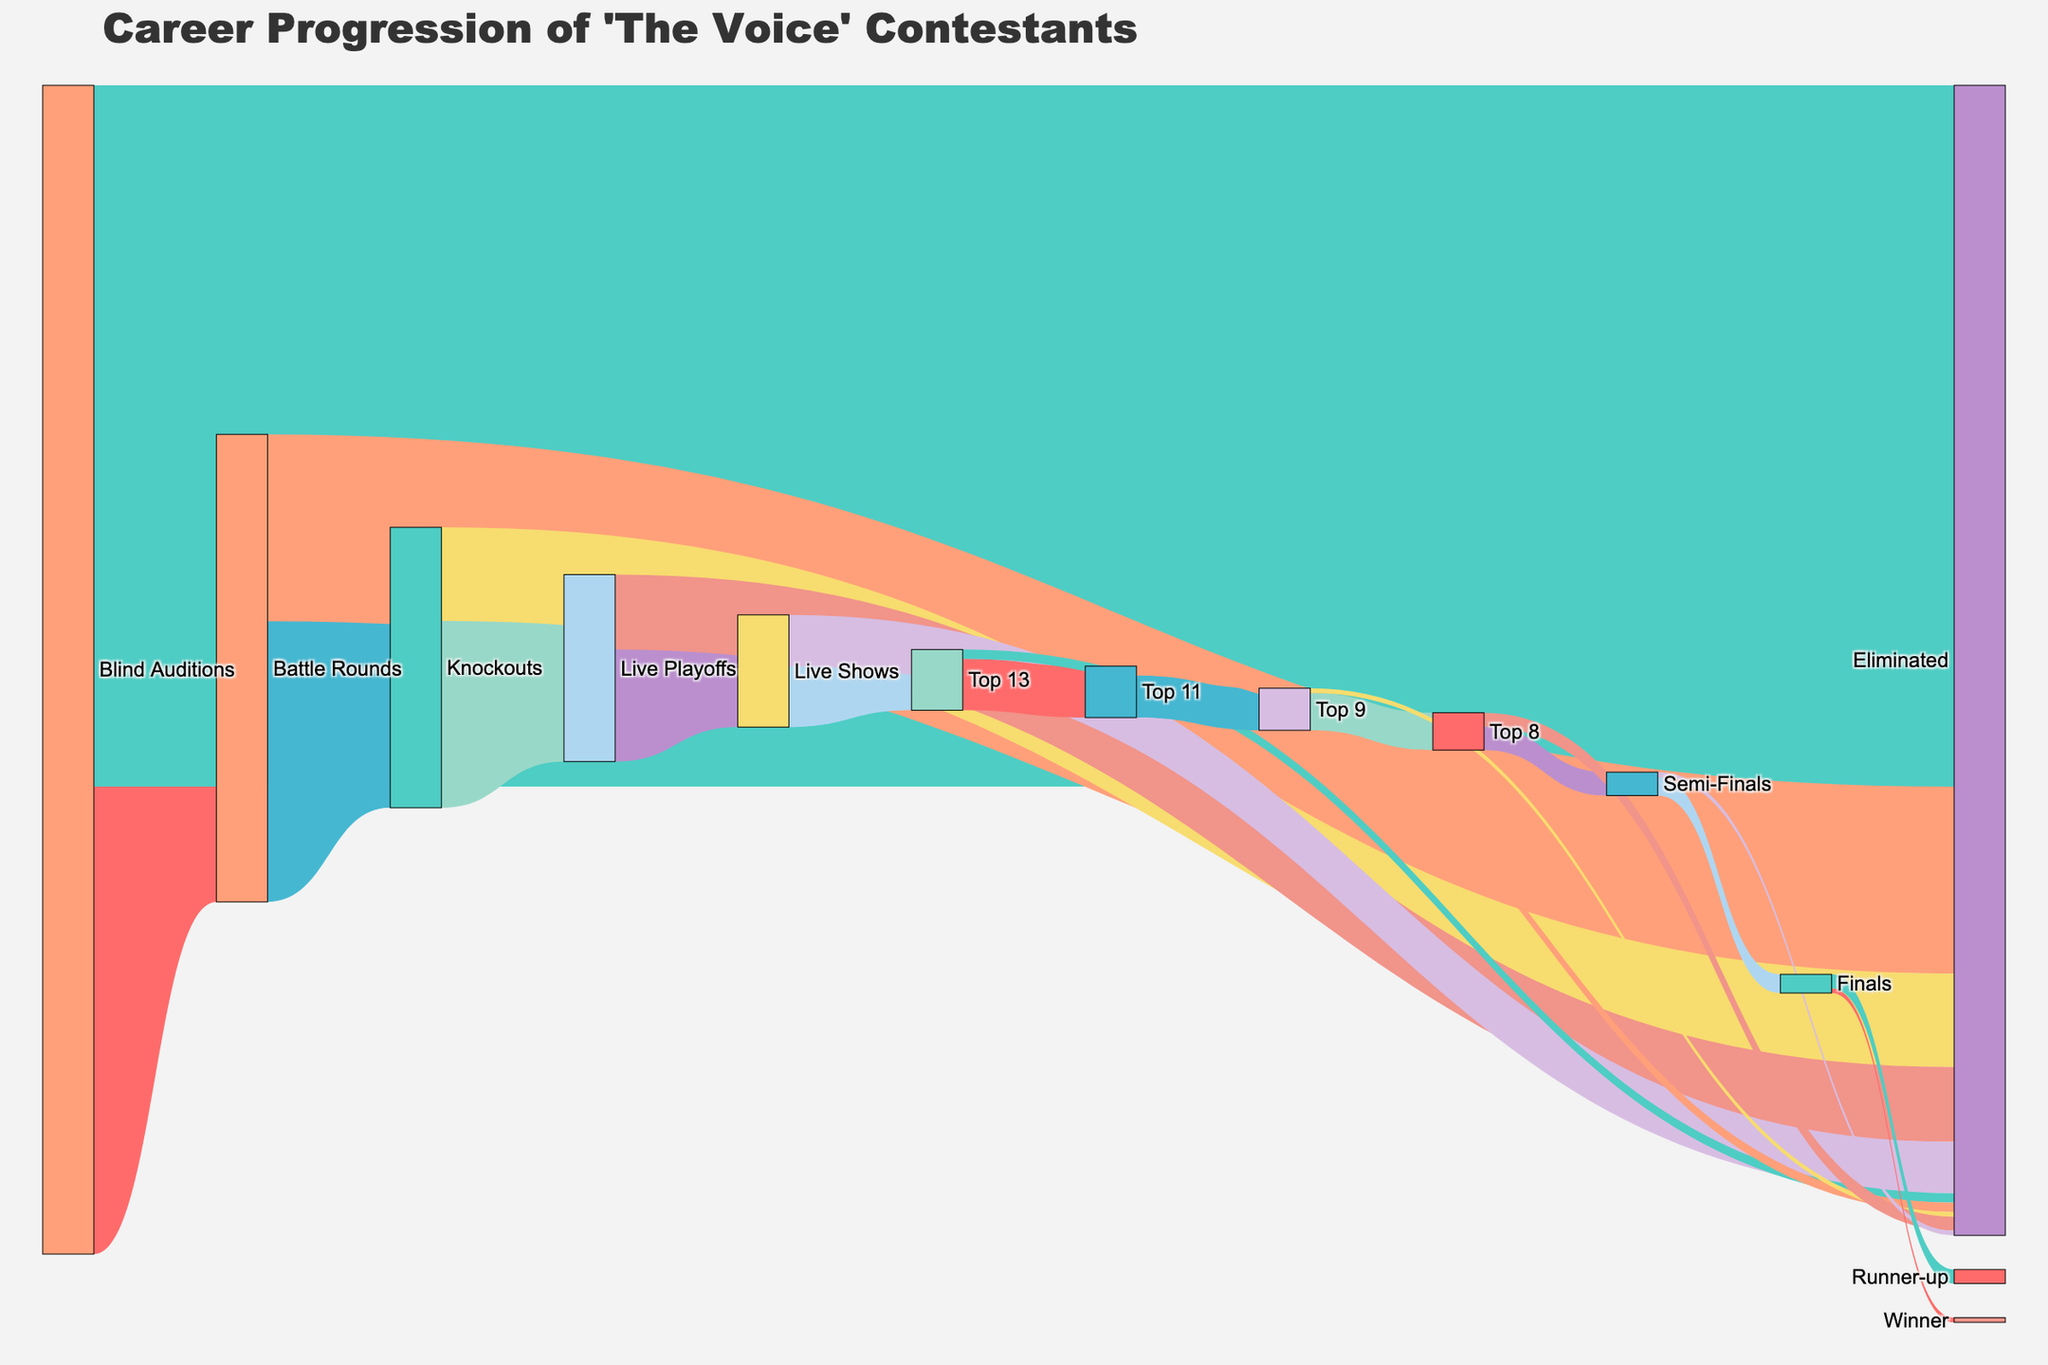What is the title of the Sankey Diagram? The title of the figure is usually displayed at the top of the diagram. In this case, it shows "Career Progression of 'The Voice' Contestants".
Answer: Career Progression of 'The Voice' Contestants How many contestants were eliminated during the Blind Auditions phase? By looking at the flow from "Blind Auditions" to "Eliminated", we see a value of 150 contestants.
Answer: 150 How many contestants made it to the Battle Rounds from the Blind Auditions? From "Blind Auditions" to "Battle Rounds", we see that 100 contestants advanced.
Answer: 100 What is the total number of contestants who reached the Live Playoffs? By summing up the values from "Knockouts" to "Live Playoffs" (40) and from "Knockouts" to "Eliminated" (20), we conclude that 40 contestants reached the Live Playoffs.
Answer: 40 How many contestants were eliminated during the Live Shows? From the "Live Shows" phase to "Eliminated", the value is 11.
Answer: 11 How many contestants did not make it to the Top 13 from the Live Shows? The value transitioning from "Live Shows" to "Eliminated" is 11, so 11 contestants did not make it to the Top 13.
Answer: 11 Compare the number of contestants who proceeded to the Knockouts from the Battle Rounds with those eliminated in the same phase. Which group is larger and by how much? In the Battle Rounds, 60 moved to the Knockouts and 40 were eliminated. Comparing these, 60 - 40 = 20, so those who proceeded are larger by 20.
Answer: Proceeded group is larger by 20 How many phases are there between the Blind Auditions and the Finals? By following the Sankey flow from "Blind Auditions" to "Finals", we count the phases: Battle Rounds, Knockouts, Live Playoffs, Live Shows, Top 13, Top 11, Top 9, Top 8, Semi-Finals, making it a total of 8 phases.
Answer: 8 phases What is the ratio of contestants who made it to the Top 9 to those who got eliminated in the Top 11 phase? The number of contestants who made it to the Top 9 is 9, and the number eliminated in the Top 11 phase is 2. The ratio is 9:2.
Answer: 9:2 How many contestants were there in the Semi-Finals compared to those eliminated directly before it? From the "Top 8" phase, 5 contestants moved to the "Semi-Finals" and 3 were eliminated. So, 5 compared to 3.
Answer: 5 to 3 